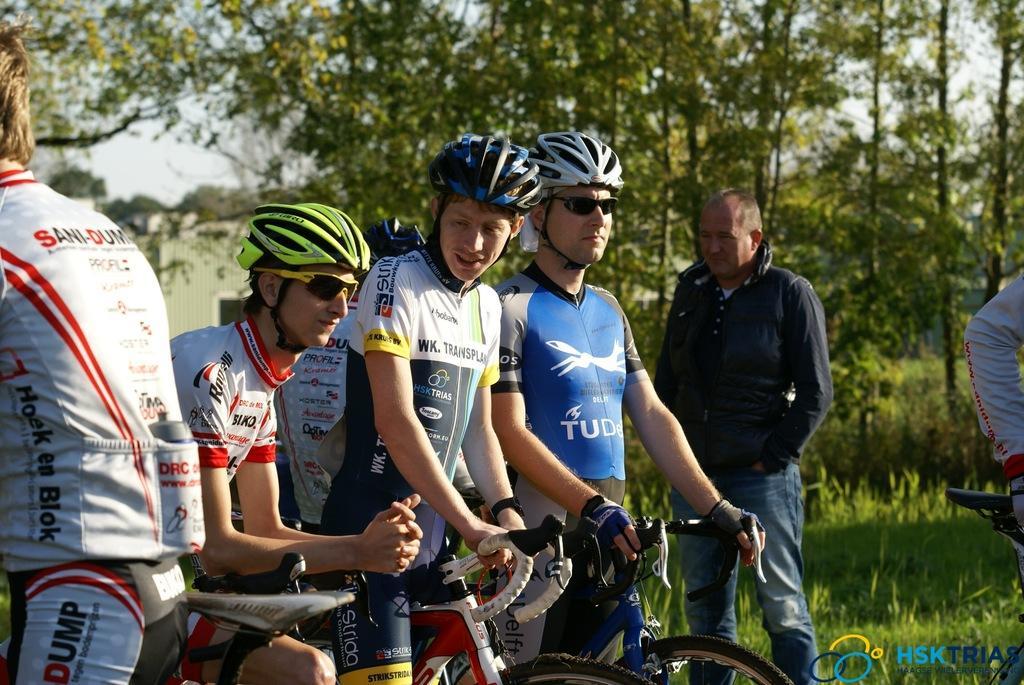Can you describe this image briefly? In this image I see few men and these are with the cycle and they are wearing helmets. In the background I see the trees and the grass. 